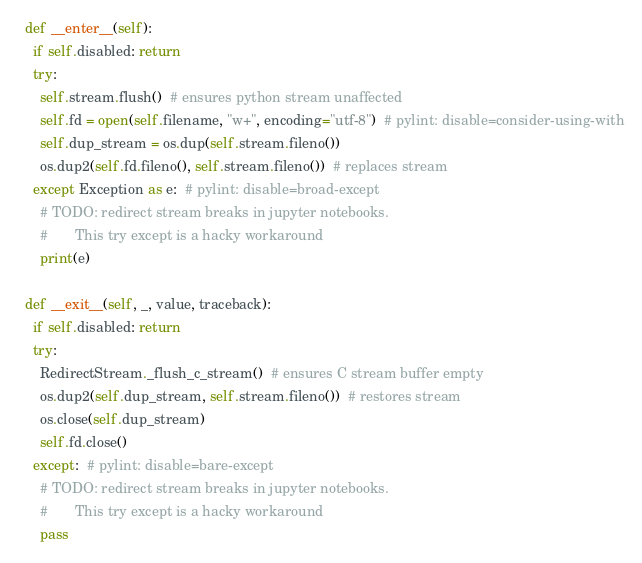<code> <loc_0><loc_0><loc_500><loc_500><_Python_>
  def __enter__(self):
    if self.disabled: return
    try:
      self.stream.flush()  # ensures python stream unaffected
      self.fd = open(self.filename, "w+", encoding="utf-8")  # pylint: disable=consider-using-with
      self.dup_stream = os.dup(self.stream.fileno())
      os.dup2(self.fd.fileno(), self.stream.fileno())  # replaces stream
    except Exception as e:  # pylint: disable=broad-except
      # TODO: redirect stream breaks in jupyter notebooks.
      #       This try except is a hacky workaround
      print(e)

  def __exit__(self, _, value, traceback):
    if self.disabled: return
    try:
      RedirectStream._flush_c_stream()  # ensures C stream buffer empty
      os.dup2(self.dup_stream, self.stream.fileno())  # restores stream
      os.close(self.dup_stream)
      self.fd.close()
    except:  # pylint: disable=bare-except
      # TODO: redirect stream breaks in jupyter notebooks.
      #       This try except is a hacky workaround
      pass
</code> 